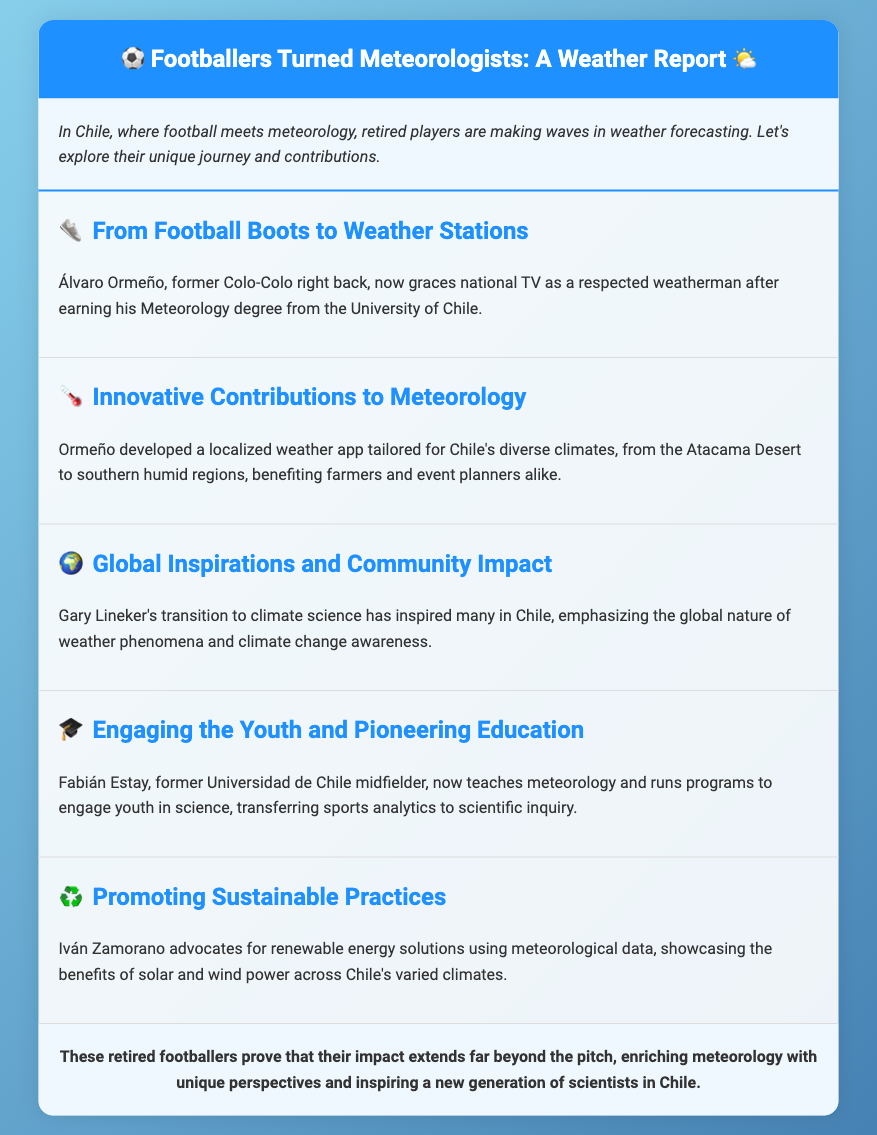What is the name of the former Colo-Colo player turned weatherman? Álvaro Ormeño is mentioned in the document as the former Colo-Colo right back who is now a weatherman.
Answer: Álvaro Ormeño What degree did Álvaro Ormeño earn? The document states that he earned a Meteorology degree from the University of Chile.
Answer: Meteorology degree Which retired footballer teaches meteorology? Fabián Estay is mentioned as the former Universidad de Chile midfielder who teaches meteorology.
Answer: Fabián Estay What unique app did Álvaro Ormeño develop? The document discusses a localized weather app tailored for Chile's diverse climates created by Ormeño.
Answer: Localized weather app Who advocates for renewable energy solutions? Iván Zamorano is mentioned as advocating for renewable energy solutions using meteorological data.
Answer: Iván Zamorano What is the impact of Gary Lineker's transition to climate science? The document notes that Gary Lineker's transition inspires many in Chile, raising awareness about climate change.
Answer: Inspires many What role does Fabián Estay play in education? He runs programs to engage youth in science, focusing on transferring sports analytics to scientific inquiry.
Answer: Engaging youth in science How does Iván Zamorano utilize meteorological data? He showcases the benefits of solar and wind power across Chile's varied climates using this data.
Answer: Advocating for renewable energy solutions 